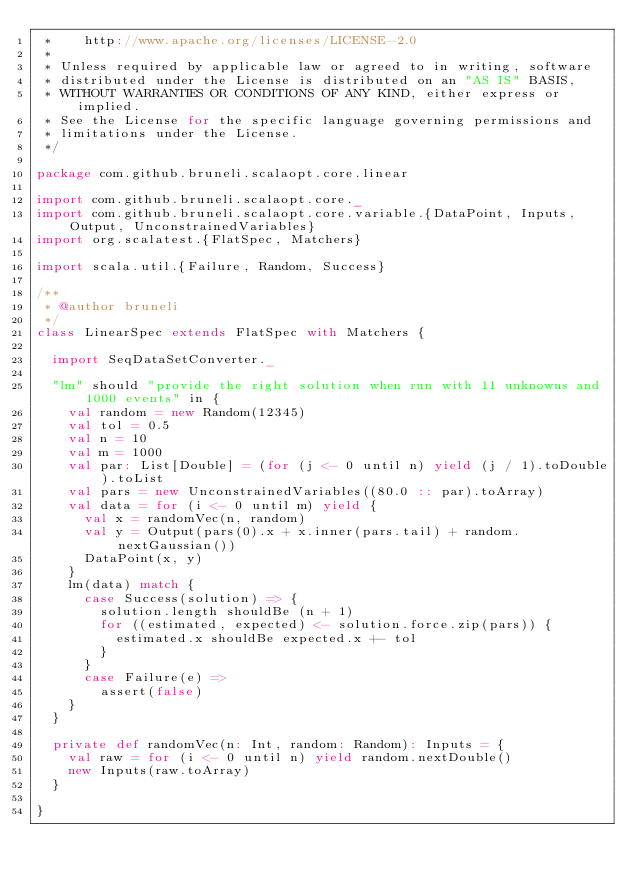<code> <loc_0><loc_0><loc_500><loc_500><_Scala_> *    http://www.apache.org/licenses/LICENSE-2.0
 *
 * Unless required by applicable law or agreed to in writing, software
 * distributed under the License is distributed on an "AS IS" BASIS,
 * WITHOUT WARRANTIES OR CONDITIONS OF ANY KIND, either express or implied.
 * See the License for the specific language governing permissions and
 * limitations under the License.
 */

package com.github.bruneli.scalaopt.core.linear

import com.github.bruneli.scalaopt.core._
import com.github.bruneli.scalaopt.core.variable.{DataPoint, Inputs, Output, UnconstrainedVariables}
import org.scalatest.{FlatSpec, Matchers}

import scala.util.{Failure, Random, Success}

/**
 * @author bruneli
 */
class LinearSpec extends FlatSpec with Matchers {

  import SeqDataSetConverter._

  "lm" should "provide the right solution when run with 11 unknowns and 1000 events" in {
    val random = new Random(12345)
    val tol = 0.5
    val n = 10
    val m = 1000
    val par: List[Double] = (for (j <- 0 until n) yield (j / 1).toDouble).toList
    val pars = new UnconstrainedVariables((80.0 :: par).toArray)
    val data = for (i <- 0 until m) yield {
      val x = randomVec(n, random)
      val y = Output(pars(0).x + x.inner(pars.tail) + random.nextGaussian())
      DataPoint(x, y)
    }
    lm(data) match {
      case Success(solution) => {
        solution.length shouldBe (n + 1)
        for ((estimated, expected) <- solution.force.zip(pars)) {
          estimated.x shouldBe expected.x +- tol
        }
      }
      case Failure(e) =>
        assert(false)
    }
  }

  private def randomVec(n: Int, random: Random): Inputs = {
    val raw = for (i <- 0 until n) yield random.nextDouble()
    new Inputs(raw.toArray)
  }

}
</code> 